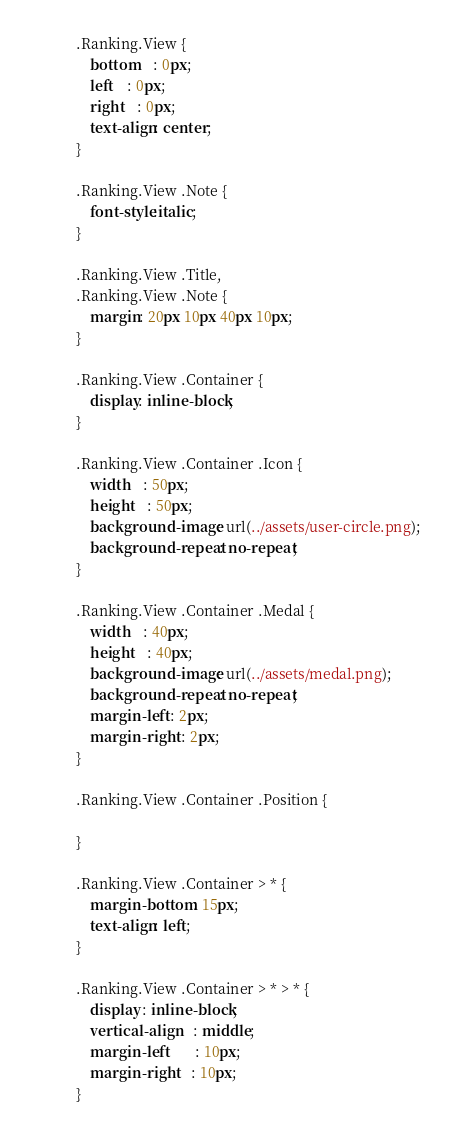<code> <loc_0><loc_0><loc_500><loc_500><_CSS_>.Ranking.View {
    bottom	: 0px;
    left	: 0px;
    right	: 0px;
    text-align: center;
}

.Ranking.View .Note {
	font-style:italic;
}

.Ranking.View .Title,
.Ranking.View .Note {
    margin: 20px 10px 40px 10px;
}

.Ranking.View .Container {
	display: inline-block;
}

.Ranking.View .Container .Icon {
	width 	: 50px;
	height 	: 50px;
	background-image: url(../assets/user-circle.png);
    background-repeat: no-repeat;
}

.Ranking.View .Container .Medal {
	width 	: 40px;
	height 	: 40px;
	background-image: url(../assets/medal.png);
    background-repeat: no-repeat;
	margin-left : 2px;
	margin-right : 2px;
}

.Ranking.View .Container .Position {
	
}

.Ranking.View .Container > * {
    margin-bottom: 15px;
    text-align: left;
}

.Ranking.View .Container > * > * {
	display : inline-block;
	vertical-align	: middle;
	margin-left		: 10px;
	margin-right	: 10px;
}</code> 